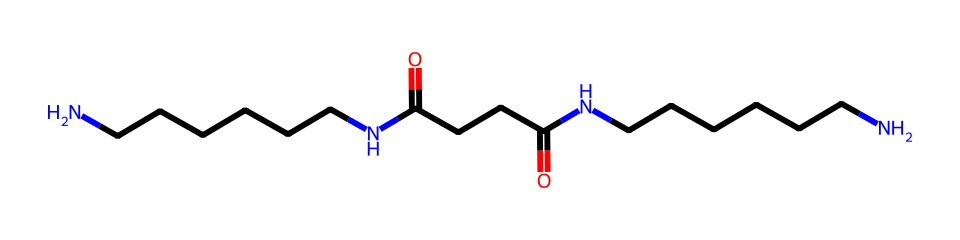What type of polymer is represented by this chemical structure? The structure features repeating amide linkages, indicating that it belongs to the family of polyamides. This classification points to nylon, which is a polyamide widely used in fibers and textiles.
Answer: polyamide How many nitrogen atoms are present in the structure? By examining the SMILES representation, we can count the number of nitrogen atoms. There are two "N" symbols in the sequence, which indicates two nitrogen atoms are present.
Answer: 2 What is the primary functional group observed in this chemical? The presence of multiple carbonyl groups (C=O) adjacent to nitrogen suggests that the primary functional group is an amide due to the combination of these carbonyls with nitrogen atoms.
Answer: amide What is the total number of carbon atoms in the chemical? Counting the "C" symbols in the SMILES representation, there are a total of 12 carbon atoms, as represented in the sequence.
Answer: 12 What type of bonding primarily holds this nylon fiber together? The presence of strong polar covalent bonds in the amide linkages between carbonyl and nitrogen components shows that hydrogen bonding also plays a significant role in stabilizing the fiber structure.
Answer: hydrogen bonding Which physical property is enhanced in nylon fibers due to their chemical structure? The linear arrangement and ability to form hydrogen bonds contribute to increased tensile strength and durability, commonly noted in nylon fibers, which enhance their use in orthopedic braces.
Answer: tensile strength 